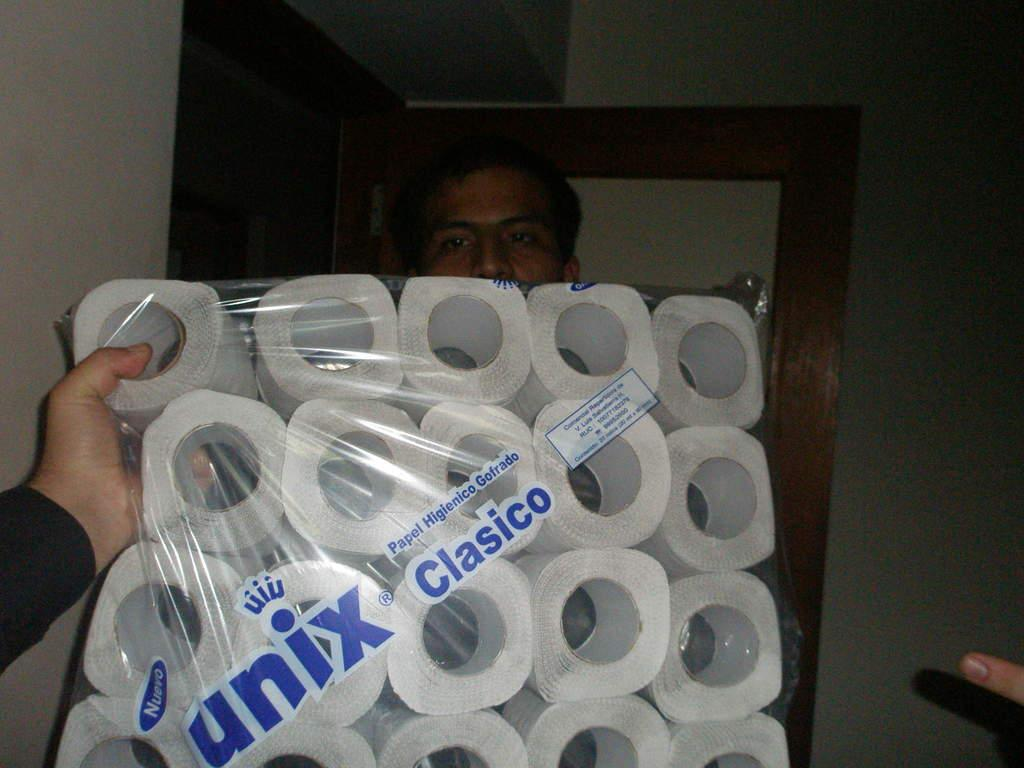What is the main subject of the image? There is a person holding a cover of paper rolls in the image. Can you describe the other person in the image? There is another person standing in the image. What type of pig can be seen playing with the ice in the image? There is no pig or ice present in the image. Is the camera visible in the image? The image does not show a camera; it only features two people. 